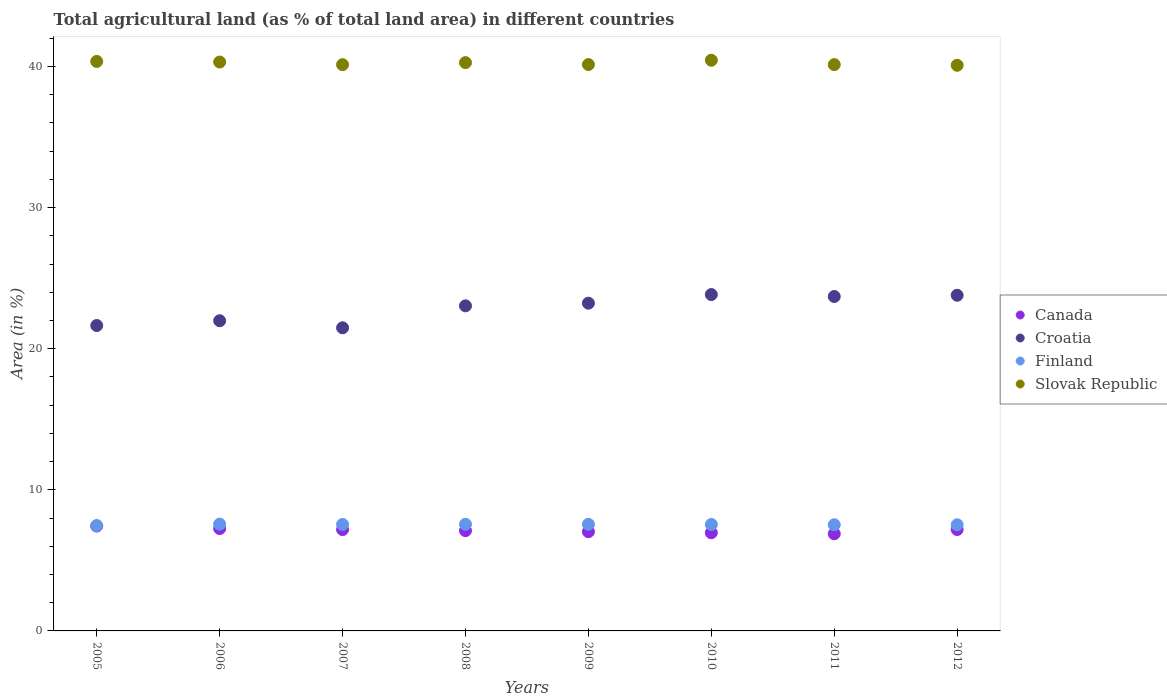How many different coloured dotlines are there?
Your response must be concise. 4. Is the number of dotlines equal to the number of legend labels?
Your response must be concise. Yes. What is the percentage of agricultural land in Slovak Republic in 2010?
Give a very brief answer. 40.44. Across all years, what is the maximum percentage of agricultural land in Croatia?
Offer a terse response. 23.83. Across all years, what is the minimum percentage of agricultural land in Canada?
Offer a very short reply. 6.88. In which year was the percentage of agricultural land in Croatia maximum?
Your response must be concise. 2010. In which year was the percentage of agricultural land in Canada minimum?
Give a very brief answer. 2011. What is the total percentage of agricultural land in Slovak Republic in the graph?
Ensure brevity in your answer.  321.84. What is the difference between the percentage of agricultural land in Croatia in 2005 and that in 2008?
Keep it short and to the point. -1.4. What is the difference between the percentage of agricultural land in Slovak Republic in 2011 and the percentage of agricultural land in Finland in 2009?
Your response must be concise. 32.57. What is the average percentage of agricultural land in Canada per year?
Your response must be concise. 7.13. In the year 2007, what is the difference between the percentage of agricultural land in Croatia and percentage of agricultural land in Canada?
Give a very brief answer. 14.3. What is the ratio of the percentage of agricultural land in Croatia in 2005 to that in 2007?
Provide a succinct answer. 1.01. What is the difference between the highest and the second highest percentage of agricultural land in Finland?
Provide a short and direct response. 0.01. What is the difference between the highest and the lowest percentage of agricultural land in Finland?
Provide a short and direct response. 0.1. Is it the case that in every year, the sum of the percentage of agricultural land in Croatia and percentage of agricultural land in Canada  is greater than the sum of percentage of agricultural land in Slovak Republic and percentage of agricultural land in Finland?
Offer a terse response. Yes. Is the percentage of agricultural land in Finland strictly less than the percentage of agricultural land in Croatia over the years?
Your answer should be very brief. Yes. How many dotlines are there?
Your answer should be compact. 4. How many years are there in the graph?
Offer a terse response. 8. Where does the legend appear in the graph?
Ensure brevity in your answer.  Center right. How many legend labels are there?
Your response must be concise. 4. How are the legend labels stacked?
Offer a terse response. Vertical. What is the title of the graph?
Your answer should be very brief. Total agricultural land (as % of total land area) in different countries. Does "Tonga" appear as one of the legend labels in the graph?
Keep it short and to the point. No. What is the label or title of the Y-axis?
Your answer should be very brief. Area (in %). What is the Area (in %) in Canada in 2005?
Provide a short and direct response. 7.43. What is the Area (in %) in Croatia in 2005?
Provide a short and direct response. 21.64. What is the Area (in %) of Finland in 2005?
Ensure brevity in your answer.  7.47. What is the Area (in %) of Slovak Republic in 2005?
Make the answer very short. 40.35. What is the Area (in %) of Canada in 2006?
Your answer should be compact. 7.25. What is the Area (in %) in Croatia in 2006?
Provide a short and direct response. 21.98. What is the Area (in %) in Finland in 2006?
Your answer should be compact. 7.57. What is the Area (in %) of Slovak Republic in 2006?
Ensure brevity in your answer.  40.31. What is the Area (in %) in Canada in 2007?
Provide a succinct answer. 7.18. What is the Area (in %) of Croatia in 2007?
Make the answer very short. 21.48. What is the Area (in %) in Finland in 2007?
Your response must be concise. 7.55. What is the Area (in %) of Slovak Republic in 2007?
Offer a very short reply. 40.12. What is the Area (in %) of Canada in 2008?
Ensure brevity in your answer.  7.11. What is the Area (in %) of Croatia in 2008?
Offer a terse response. 23.04. What is the Area (in %) in Finland in 2008?
Offer a very short reply. 7.56. What is the Area (in %) of Slovak Republic in 2008?
Your response must be concise. 40.27. What is the Area (in %) of Canada in 2009?
Your answer should be very brief. 7.03. What is the Area (in %) in Croatia in 2009?
Ensure brevity in your answer.  23.22. What is the Area (in %) in Finland in 2009?
Your response must be concise. 7.56. What is the Area (in %) of Slovak Republic in 2009?
Make the answer very short. 40.13. What is the Area (in %) in Canada in 2010?
Provide a short and direct response. 6.96. What is the Area (in %) of Croatia in 2010?
Keep it short and to the point. 23.83. What is the Area (in %) of Finland in 2010?
Keep it short and to the point. 7.54. What is the Area (in %) in Slovak Republic in 2010?
Offer a very short reply. 40.44. What is the Area (in %) in Canada in 2011?
Your answer should be compact. 6.88. What is the Area (in %) of Croatia in 2011?
Make the answer very short. 23.7. What is the Area (in %) of Finland in 2011?
Your answer should be very brief. 7.52. What is the Area (in %) in Slovak Republic in 2011?
Provide a short and direct response. 40.13. What is the Area (in %) in Canada in 2012?
Your response must be concise. 7.19. What is the Area (in %) in Croatia in 2012?
Provide a succinct answer. 23.78. What is the Area (in %) of Finland in 2012?
Keep it short and to the point. 7.52. What is the Area (in %) of Slovak Republic in 2012?
Your response must be concise. 40.08. Across all years, what is the maximum Area (in %) of Canada?
Ensure brevity in your answer.  7.43. Across all years, what is the maximum Area (in %) of Croatia?
Provide a short and direct response. 23.83. Across all years, what is the maximum Area (in %) of Finland?
Provide a short and direct response. 7.57. Across all years, what is the maximum Area (in %) of Slovak Republic?
Your answer should be compact. 40.44. Across all years, what is the minimum Area (in %) of Canada?
Your answer should be compact. 6.88. Across all years, what is the minimum Area (in %) in Croatia?
Keep it short and to the point. 21.48. Across all years, what is the minimum Area (in %) in Finland?
Give a very brief answer. 7.47. Across all years, what is the minimum Area (in %) of Slovak Republic?
Ensure brevity in your answer.  40.08. What is the total Area (in %) in Canada in the graph?
Keep it short and to the point. 57.03. What is the total Area (in %) in Croatia in the graph?
Offer a very short reply. 182.68. What is the total Area (in %) of Finland in the graph?
Make the answer very short. 60.28. What is the total Area (in %) of Slovak Republic in the graph?
Your response must be concise. 321.84. What is the difference between the Area (in %) in Canada in 2005 and that in 2006?
Your answer should be very brief. 0.18. What is the difference between the Area (in %) in Croatia in 2005 and that in 2006?
Your answer should be compact. -0.34. What is the difference between the Area (in %) of Finland in 2005 and that in 2006?
Your response must be concise. -0.1. What is the difference between the Area (in %) in Slovak Republic in 2005 and that in 2006?
Ensure brevity in your answer.  0.04. What is the difference between the Area (in %) in Canada in 2005 and that in 2007?
Provide a succinct answer. 0.25. What is the difference between the Area (in %) of Croatia in 2005 and that in 2007?
Your answer should be compact. 0.16. What is the difference between the Area (in %) in Finland in 2005 and that in 2007?
Make the answer very short. -0.08. What is the difference between the Area (in %) of Slovak Republic in 2005 and that in 2007?
Offer a terse response. 0.23. What is the difference between the Area (in %) in Canada in 2005 and that in 2008?
Your response must be concise. 0.33. What is the difference between the Area (in %) in Croatia in 2005 and that in 2008?
Provide a short and direct response. -1.4. What is the difference between the Area (in %) of Finland in 2005 and that in 2008?
Offer a very short reply. -0.09. What is the difference between the Area (in %) in Slovak Republic in 2005 and that in 2008?
Your answer should be compact. 0.08. What is the difference between the Area (in %) of Canada in 2005 and that in 2009?
Provide a succinct answer. 0.4. What is the difference between the Area (in %) in Croatia in 2005 and that in 2009?
Provide a short and direct response. -1.58. What is the difference between the Area (in %) of Finland in 2005 and that in 2009?
Your answer should be compact. -0.09. What is the difference between the Area (in %) in Slovak Republic in 2005 and that in 2009?
Keep it short and to the point. 0.22. What is the difference between the Area (in %) of Canada in 2005 and that in 2010?
Provide a short and direct response. 0.47. What is the difference between the Area (in %) of Croatia in 2005 and that in 2010?
Offer a very short reply. -2.19. What is the difference between the Area (in %) of Finland in 2005 and that in 2010?
Provide a succinct answer. -0.08. What is the difference between the Area (in %) of Slovak Republic in 2005 and that in 2010?
Ensure brevity in your answer.  -0.08. What is the difference between the Area (in %) of Canada in 2005 and that in 2011?
Your answer should be very brief. 0.55. What is the difference between the Area (in %) in Croatia in 2005 and that in 2011?
Keep it short and to the point. -2.06. What is the difference between the Area (in %) in Finland in 2005 and that in 2011?
Your answer should be very brief. -0.06. What is the difference between the Area (in %) in Slovak Republic in 2005 and that in 2011?
Provide a short and direct response. 0.22. What is the difference between the Area (in %) in Canada in 2005 and that in 2012?
Offer a very short reply. 0.24. What is the difference between the Area (in %) of Croatia in 2005 and that in 2012?
Offer a very short reply. -2.14. What is the difference between the Area (in %) in Finland in 2005 and that in 2012?
Ensure brevity in your answer.  -0.05. What is the difference between the Area (in %) of Slovak Republic in 2005 and that in 2012?
Your response must be concise. 0.27. What is the difference between the Area (in %) in Canada in 2006 and that in 2007?
Provide a succinct answer. 0.07. What is the difference between the Area (in %) of Croatia in 2006 and that in 2007?
Provide a short and direct response. 0.5. What is the difference between the Area (in %) in Finland in 2006 and that in 2007?
Your response must be concise. 0.02. What is the difference between the Area (in %) in Slovak Republic in 2006 and that in 2007?
Your response must be concise. 0.19. What is the difference between the Area (in %) in Canada in 2006 and that in 2008?
Ensure brevity in your answer.  0.15. What is the difference between the Area (in %) of Croatia in 2006 and that in 2008?
Give a very brief answer. -1.06. What is the difference between the Area (in %) in Finland in 2006 and that in 2008?
Offer a very short reply. 0.01. What is the difference between the Area (in %) of Slovak Republic in 2006 and that in 2008?
Offer a very short reply. 0.04. What is the difference between the Area (in %) in Canada in 2006 and that in 2009?
Provide a short and direct response. 0.22. What is the difference between the Area (in %) of Croatia in 2006 and that in 2009?
Your answer should be compact. -1.24. What is the difference between the Area (in %) of Finland in 2006 and that in 2009?
Ensure brevity in your answer.  0.01. What is the difference between the Area (in %) of Slovak Republic in 2006 and that in 2009?
Your response must be concise. 0.18. What is the difference between the Area (in %) in Canada in 2006 and that in 2010?
Give a very brief answer. 0.3. What is the difference between the Area (in %) of Croatia in 2006 and that in 2010?
Your answer should be very brief. -1.85. What is the difference between the Area (in %) in Finland in 2006 and that in 2010?
Give a very brief answer. 0.02. What is the difference between the Area (in %) of Slovak Republic in 2006 and that in 2010?
Make the answer very short. -0.13. What is the difference between the Area (in %) in Canada in 2006 and that in 2011?
Give a very brief answer. 0.37. What is the difference between the Area (in %) of Croatia in 2006 and that in 2011?
Offer a very short reply. -1.72. What is the difference between the Area (in %) in Finland in 2006 and that in 2011?
Offer a very short reply. 0.04. What is the difference between the Area (in %) of Slovak Republic in 2006 and that in 2011?
Ensure brevity in your answer.  0.18. What is the difference between the Area (in %) in Canada in 2006 and that in 2012?
Ensure brevity in your answer.  0.07. What is the difference between the Area (in %) in Croatia in 2006 and that in 2012?
Provide a succinct answer. -1.8. What is the difference between the Area (in %) in Finland in 2006 and that in 2012?
Give a very brief answer. 0.05. What is the difference between the Area (in %) of Slovak Republic in 2006 and that in 2012?
Offer a very short reply. 0.23. What is the difference between the Area (in %) in Canada in 2007 and that in 2008?
Provide a succinct answer. 0.07. What is the difference between the Area (in %) in Croatia in 2007 and that in 2008?
Provide a succinct answer. -1.56. What is the difference between the Area (in %) of Finland in 2007 and that in 2008?
Your response must be concise. -0.01. What is the difference between the Area (in %) of Slovak Republic in 2007 and that in 2008?
Your response must be concise. -0.15. What is the difference between the Area (in %) in Canada in 2007 and that in 2009?
Your answer should be compact. 0.15. What is the difference between the Area (in %) of Croatia in 2007 and that in 2009?
Your answer should be compact. -1.74. What is the difference between the Area (in %) in Finland in 2007 and that in 2009?
Keep it short and to the point. -0.01. What is the difference between the Area (in %) in Slovak Republic in 2007 and that in 2009?
Ensure brevity in your answer.  -0.01. What is the difference between the Area (in %) in Canada in 2007 and that in 2010?
Your answer should be compact. 0.22. What is the difference between the Area (in %) in Croatia in 2007 and that in 2010?
Provide a succinct answer. -2.36. What is the difference between the Area (in %) of Finland in 2007 and that in 2010?
Your answer should be compact. 0.01. What is the difference between the Area (in %) in Slovak Republic in 2007 and that in 2010?
Provide a succinct answer. -0.31. What is the difference between the Area (in %) of Canada in 2007 and that in 2011?
Your answer should be very brief. 0.3. What is the difference between the Area (in %) of Croatia in 2007 and that in 2011?
Provide a short and direct response. -2.22. What is the difference between the Area (in %) of Finland in 2007 and that in 2011?
Give a very brief answer. 0.02. What is the difference between the Area (in %) of Slovak Republic in 2007 and that in 2011?
Offer a terse response. -0. What is the difference between the Area (in %) in Canada in 2007 and that in 2012?
Offer a terse response. -0.01. What is the difference between the Area (in %) in Croatia in 2007 and that in 2012?
Offer a very short reply. -2.31. What is the difference between the Area (in %) of Finland in 2007 and that in 2012?
Your response must be concise. 0.03. What is the difference between the Area (in %) of Slovak Republic in 2007 and that in 2012?
Offer a very short reply. 0.04. What is the difference between the Area (in %) of Canada in 2008 and that in 2009?
Give a very brief answer. 0.07. What is the difference between the Area (in %) in Croatia in 2008 and that in 2009?
Keep it short and to the point. -0.19. What is the difference between the Area (in %) of Finland in 2008 and that in 2009?
Ensure brevity in your answer.  -0. What is the difference between the Area (in %) in Slovak Republic in 2008 and that in 2009?
Make the answer very short. 0.14. What is the difference between the Area (in %) in Canada in 2008 and that in 2010?
Provide a short and direct response. 0.15. What is the difference between the Area (in %) of Croatia in 2008 and that in 2010?
Provide a succinct answer. -0.8. What is the difference between the Area (in %) in Finland in 2008 and that in 2010?
Keep it short and to the point. 0.01. What is the difference between the Area (in %) in Slovak Republic in 2008 and that in 2010?
Give a very brief answer. -0.17. What is the difference between the Area (in %) in Canada in 2008 and that in 2011?
Ensure brevity in your answer.  0.22. What is the difference between the Area (in %) in Croatia in 2008 and that in 2011?
Your answer should be compact. -0.66. What is the difference between the Area (in %) in Finland in 2008 and that in 2011?
Offer a very short reply. 0.03. What is the difference between the Area (in %) in Slovak Republic in 2008 and that in 2011?
Your response must be concise. 0.14. What is the difference between the Area (in %) in Canada in 2008 and that in 2012?
Provide a succinct answer. -0.08. What is the difference between the Area (in %) of Croatia in 2008 and that in 2012?
Ensure brevity in your answer.  -0.75. What is the difference between the Area (in %) in Finland in 2008 and that in 2012?
Your answer should be very brief. 0.04. What is the difference between the Area (in %) in Slovak Republic in 2008 and that in 2012?
Your answer should be compact. 0.19. What is the difference between the Area (in %) in Canada in 2009 and that in 2010?
Your answer should be compact. 0.07. What is the difference between the Area (in %) of Croatia in 2009 and that in 2010?
Ensure brevity in your answer.  -0.61. What is the difference between the Area (in %) of Finland in 2009 and that in 2010?
Keep it short and to the point. 0.02. What is the difference between the Area (in %) of Slovak Republic in 2009 and that in 2010?
Your answer should be compact. -0.3. What is the difference between the Area (in %) in Canada in 2009 and that in 2011?
Provide a short and direct response. 0.15. What is the difference between the Area (in %) of Croatia in 2009 and that in 2011?
Your response must be concise. -0.47. What is the difference between the Area (in %) of Finland in 2009 and that in 2011?
Provide a succinct answer. 0.03. What is the difference between the Area (in %) in Slovak Republic in 2009 and that in 2011?
Provide a succinct answer. 0. What is the difference between the Area (in %) of Canada in 2009 and that in 2012?
Provide a short and direct response. -0.15. What is the difference between the Area (in %) of Croatia in 2009 and that in 2012?
Keep it short and to the point. -0.56. What is the difference between the Area (in %) of Finland in 2009 and that in 2012?
Provide a short and direct response. 0.04. What is the difference between the Area (in %) in Slovak Republic in 2009 and that in 2012?
Make the answer very short. 0.05. What is the difference between the Area (in %) in Canada in 2010 and that in 2011?
Give a very brief answer. 0.07. What is the difference between the Area (in %) of Croatia in 2010 and that in 2011?
Keep it short and to the point. 0.14. What is the difference between the Area (in %) in Finland in 2010 and that in 2011?
Offer a terse response. 0.02. What is the difference between the Area (in %) in Slovak Republic in 2010 and that in 2011?
Your answer should be very brief. 0.31. What is the difference between the Area (in %) of Canada in 2010 and that in 2012?
Keep it short and to the point. -0.23. What is the difference between the Area (in %) of Finland in 2010 and that in 2012?
Offer a very short reply. 0.02. What is the difference between the Area (in %) of Slovak Republic in 2010 and that in 2012?
Give a very brief answer. 0.36. What is the difference between the Area (in %) of Canada in 2011 and that in 2012?
Offer a very short reply. -0.3. What is the difference between the Area (in %) of Croatia in 2011 and that in 2012?
Keep it short and to the point. -0.09. What is the difference between the Area (in %) of Finland in 2011 and that in 2012?
Provide a succinct answer. 0. What is the difference between the Area (in %) of Slovak Republic in 2011 and that in 2012?
Ensure brevity in your answer.  0.05. What is the difference between the Area (in %) of Canada in 2005 and the Area (in %) of Croatia in 2006?
Your response must be concise. -14.55. What is the difference between the Area (in %) in Canada in 2005 and the Area (in %) in Finland in 2006?
Ensure brevity in your answer.  -0.14. What is the difference between the Area (in %) in Canada in 2005 and the Area (in %) in Slovak Republic in 2006?
Give a very brief answer. -32.88. What is the difference between the Area (in %) in Croatia in 2005 and the Area (in %) in Finland in 2006?
Give a very brief answer. 14.07. What is the difference between the Area (in %) in Croatia in 2005 and the Area (in %) in Slovak Republic in 2006?
Give a very brief answer. -18.67. What is the difference between the Area (in %) in Finland in 2005 and the Area (in %) in Slovak Republic in 2006?
Provide a succinct answer. -32.85. What is the difference between the Area (in %) of Canada in 2005 and the Area (in %) of Croatia in 2007?
Make the answer very short. -14.05. What is the difference between the Area (in %) in Canada in 2005 and the Area (in %) in Finland in 2007?
Your response must be concise. -0.12. What is the difference between the Area (in %) of Canada in 2005 and the Area (in %) of Slovak Republic in 2007?
Provide a succinct answer. -32.69. What is the difference between the Area (in %) of Croatia in 2005 and the Area (in %) of Finland in 2007?
Your answer should be compact. 14.09. What is the difference between the Area (in %) in Croatia in 2005 and the Area (in %) in Slovak Republic in 2007?
Your answer should be very brief. -18.48. What is the difference between the Area (in %) of Finland in 2005 and the Area (in %) of Slovak Republic in 2007?
Provide a succinct answer. -32.66. What is the difference between the Area (in %) in Canada in 2005 and the Area (in %) in Croatia in 2008?
Offer a very short reply. -15.61. What is the difference between the Area (in %) in Canada in 2005 and the Area (in %) in Finland in 2008?
Make the answer very short. -0.13. What is the difference between the Area (in %) of Canada in 2005 and the Area (in %) of Slovak Republic in 2008?
Offer a very short reply. -32.84. What is the difference between the Area (in %) in Croatia in 2005 and the Area (in %) in Finland in 2008?
Provide a short and direct response. 14.08. What is the difference between the Area (in %) of Croatia in 2005 and the Area (in %) of Slovak Republic in 2008?
Your response must be concise. -18.63. What is the difference between the Area (in %) in Finland in 2005 and the Area (in %) in Slovak Republic in 2008?
Provide a succinct answer. -32.81. What is the difference between the Area (in %) in Canada in 2005 and the Area (in %) in Croatia in 2009?
Offer a very short reply. -15.79. What is the difference between the Area (in %) in Canada in 2005 and the Area (in %) in Finland in 2009?
Provide a succinct answer. -0.13. What is the difference between the Area (in %) in Canada in 2005 and the Area (in %) in Slovak Republic in 2009?
Offer a terse response. -32.7. What is the difference between the Area (in %) in Croatia in 2005 and the Area (in %) in Finland in 2009?
Give a very brief answer. 14.08. What is the difference between the Area (in %) of Croatia in 2005 and the Area (in %) of Slovak Republic in 2009?
Keep it short and to the point. -18.49. What is the difference between the Area (in %) of Finland in 2005 and the Area (in %) of Slovak Republic in 2009?
Ensure brevity in your answer.  -32.67. What is the difference between the Area (in %) of Canada in 2005 and the Area (in %) of Croatia in 2010?
Provide a succinct answer. -16.4. What is the difference between the Area (in %) of Canada in 2005 and the Area (in %) of Finland in 2010?
Your answer should be compact. -0.11. What is the difference between the Area (in %) of Canada in 2005 and the Area (in %) of Slovak Republic in 2010?
Your answer should be very brief. -33.01. What is the difference between the Area (in %) in Croatia in 2005 and the Area (in %) in Finland in 2010?
Your answer should be very brief. 14.1. What is the difference between the Area (in %) of Croatia in 2005 and the Area (in %) of Slovak Republic in 2010?
Offer a terse response. -18.8. What is the difference between the Area (in %) of Finland in 2005 and the Area (in %) of Slovak Republic in 2010?
Offer a terse response. -32.97. What is the difference between the Area (in %) in Canada in 2005 and the Area (in %) in Croatia in 2011?
Offer a very short reply. -16.27. What is the difference between the Area (in %) in Canada in 2005 and the Area (in %) in Finland in 2011?
Your answer should be compact. -0.09. What is the difference between the Area (in %) of Canada in 2005 and the Area (in %) of Slovak Republic in 2011?
Your answer should be compact. -32.7. What is the difference between the Area (in %) of Croatia in 2005 and the Area (in %) of Finland in 2011?
Offer a very short reply. 14.12. What is the difference between the Area (in %) in Croatia in 2005 and the Area (in %) in Slovak Republic in 2011?
Your response must be concise. -18.49. What is the difference between the Area (in %) in Finland in 2005 and the Area (in %) in Slovak Republic in 2011?
Your answer should be compact. -32.66. What is the difference between the Area (in %) of Canada in 2005 and the Area (in %) of Croatia in 2012?
Ensure brevity in your answer.  -16.35. What is the difference between the Area (in %) in Canada in 2005 and the Area (in %) in Finland in 2012?
Offer a terse response. -0.09. What is the difference between the Area (in %) of Canada in 2005 and the Area (in %) of Slovak Republic in 2012?
Make the answer very short. -32.65. What is the difference between the Area (in %) in Croatia in 2005 and the Area (in %) in Finland in 2012?
Offer a terse response. 14.12. What is the difference between the Area (in %) of Croatia in 2005 and the Area (in %) of Slovak Republic in 2012?
Your response must be concise. -18.44. What is the difference between the Area (in %) in Finland in 2005 and the Area (in %) in Slovak Republic in 2012?
Your answer should be very brief. -32.62. What is the difference between the Area (in %) of Canada in 2006 and the Area (in %) of Croatia in 2007?
Give a very brief answer. -14.23. What is the difference between the Area (in %) in Canada in 2006 and the Area (in %) in Finland in 2007?
Offer a terse response. -0.29. What is the difference between the Area (in %) of Canada in 2006 and the Area (in %) of Slovak Republic in 2007?
Your response must be concise. -32.87. What is the difference between the Area (in %) in Croatia in 2006 and the Area (in %) in Finland in 2007?
Give a very brief answer. 14.43. What is the difference between the Area (in %) of Croatia in 2006 and the Area (in %) of Slovak Republic in 2007?
Give a very brief answer. -18.14. What is the difference between the Area (in %) of Finland in 2006 and the Area (in %) of Slovak Republic in 2007?
Provide a succinct answer. -32.56. What is the difference between the Area (in %) in Canada in 2006 and the Area (in %) in Croatia in 2008?
Your answer should be compact. -15.78. What is the difference between the Area (in %) of Canada in 2006 and the Area (in %) of Finland in 2008?
Your answer should be very brief. -0.3. What is the difference between the Area (in %) in Canada in 2006 and the Area (in %) in Slovak Republic in 2008?
Your response must be concise. -33.02. What is the difference between the Area (in %) of Croatia in 2006 and the Area (in %) of Finland in 2008?
Ensure brevity in your answer.  14.42. What is the difference between the Area (in %) of Croatia in 2006 and the Area (in %) of Slovak Republic in 2008?
Your response must be concise. -18.29. What is the difference between the Area (in %) of Finland in 2006 and the Area (in %) of Slovak Republic in 2008?
Make the answer very short. -32.7. What is the difference between the Area (in %) of Canada in 2006 and the Area (in %) of Croatia in 2009?
Give a very brief answer. -15.97. What is the difference between the Area (in %) in Canada in 2006 and the Area (in %) in Finland in 2009?
Your answer should be very brief. -0.3. What is the difference between the Area (in %) of Canada in 2006 and the Area (in %) of Slovak Republic in 2009?
Keep it short and to the point. -32.88. What is the difference between the Area (in %) of Croatia in 2006 and the Area (in %) of Finland in 2009?
Ensure brevity in your answer.  14.42. What is the difference between the Area (in %) of Croatia in 2006 and the Area (in %) of Slovak Republic in 2009?
Give a very brief answer. -18.15. What is the difference between the Area (in %) in Finland in 2006 and the Area (in %) in Slovak Republic in 2009?
Your response must be concise. -32.57. What is the difference between the Area (in %) of Canada in 2006 and the Area (in %) of Croatia in 2010?
Make the answer very short. -16.58. What is the difference between the Area (in %) of Canada in 2006 and the Area (in %) of Finland in 2010?
Give a very brief answer. -0.29. What is the difference between the Area (in %) in Canada in 2006 and the Area (in %) in Slovak Republic in 2010?
Your answer should be very brief. -33.19. What is the difference between the Area (in %) of Croatia in 2006 and the Area (in %) of Finland in 2010?
Keep it short and to the point. 14.44. What is the difference between the Area (in %) of Croatia in 2006 and the Area (in %) of Slovak Republic in 2010?
Your answer should be very brief. -18.46. What is the difference between the Area (in %) of Finland in 2006 and the Area (in %) of Slovak Republic in 2010?
Make the answer very short. -32.87. What is the difference between the Area (in %) of Canada in 2006 and the Area (in %) of Croatia in 2011?
Keep it short and to the point. -16.44. What is the difference between the Area (in %) in Canada in 2006 and the Area (in %) in Finland in 2011?
Your answer should be very brief. -0.27. What is the difference between the Area (in %) in Canada in 2006 and the Area (in %) in Slovak Republic in 2011?
Your answer should be compact. -32.88. What is the difference between the Area (in %) in Croatia in 2006 and the Area (in %) in Finland in 2011?
Make the answer very short. 14.46. What is the difference between the Area (in %) in Croatia in 2006 and the Area (in %) in Slovak Republic in 2011?
Ensure brevity in your answer.  -18.15. What is the difference between the Area (in %) in Finland in 2006 and the Area (in %) in Slovak Republic in 2011?
Ensure brevity in your answer.  -32.56. What is the difference between the Area (in %) of Canada in 2006 and the Area (in %) of Croatia in 2012?
Keep it short and to the point. -16.53. What is the difference between the Area (in %) in Canada in 2006 and the Area (in %) in Finland in 2012?
Keep it short and to the point. -0.27. What is the difference between the Area (in %) in Canada in 2006 and the Area (in %) in Slovak Republic in 2012?
Your response must be concise. -32.83. What is the difference between the Area (in %) of Croatia in 2006 and the Area (in %) of Finland in 2012?
Give a very brief answer. 14.46. What is the difference between the Area (in %) of Croatia in 2006 and the Area (in %) of Slovak Republic in 2012?
Ensure brevity in your answer.  -18.1. What is the difference between the Area (in %) in Finland in 2006 and the Area (in %) in Slovak Republic in 2012?
Your answer should be compact. -32.52. What is the difference between the Area (in %) of Canada in 2007 and the Area (in %) of Croatia in 2008?
Your response must be concise. -15.86. What is the difference between the Area (in %) of Canada in 2007 and the Area (in %) of Finland in 2008?
Make the answer very short. -0.38. What is the difference between the Area (in %) of Canada in 2007 and the Area (in %) of Slovak Republic in 2008?
Your response must be concise. -33.09. What is the difference between the Area (in %) in Croatia in 2007 and the Area (in %) in Finland in 2008?
Your answer should be very brief. 13.92. What is the difference between the Area (in %) in Croatia in 2007 and the Area (in %) in Slovak Republic in 2008?
Keep it short and to the point. -18.79. What is the difference between the Area (in %) of Finland in 2007 and the Area (in %) of Slovak Republic in 2008?
Provide a succinct answer. -32.72. What is the difference between the Area (in %) of Canada in 2007 and the Area (in %) of Croatia in 2009?
Make the answer very short. -16.04. What is the difference between the Area (in %) in Canada in 2007 and the Area (in %) in Finland in 2009?
Offer a very short reply. -0.38. What is the difference between the Area (in %) of Canada in 2007 and the Area (in %) of Slovak Republic in 2009?
Offer a very short reply. -32.95. What is the difference between the Area (in %) of Croatia in 2007 and the Area (in %) of Finland in 2009?
Offer a very short reply. 13.92. What is the difference between the Area (in %) in Croatia in 2007 and the Area (in %) in Slovak Republic in 2009?
Your answer should be very brief. -18.65. What is the difference between the Area (in %) in Finland in 2007 and the Area (in %) in Slovak Republic in 2009?
Give a very brief answer. -32.59. What is the difference between the Area (in %) in Canada in 2007 and the Area (in %) in Croatia in 2010?
Offer a terse response. -16.66. What is the difference between the Area (in %) in Canada in 2007 and the Area (in %) in Finland in 2010?
Your response must be concise. -0.36. What is the difference between the Area (in %) of Canada in 2007 and the Area (in %) of Slovak Republic in 2010?
Offer a very short reply. -33.26. What is the difference between the Area (in %) in Croatia in 2007 and the Area (in %) in Finland in 2010?
Provide a succinct answer. 13.94. What is the difference between the Area (in %) in Croatia in 2007 and the Area (in %) in Slovak Republic in 2010?
Provide a short and direct response. -18.96. What is the difference between the Area (in %) of Finland in 2007 and the Area (in %) of Slovak Republic in 2010?
Offer a very short reply. -32.89. What is the difference between the Area (in %) in Canada in 2007 and the Area (in %) in Croatia in 2011?
Your answer should be very brief. -16.52. What is the difference between the Area (in %) in Canada in 2007 and the Area (in %) in Finland in 2011?
Keep it short and to the point. -0.35. What is the difference between the Area (in %) in Canada in 2007 and the Area (in %) in Slovak Republic in 2011?
Your answer should be compact. -32.95. What is the difference between the Area (in %) in Croatia in 2007 and the Area (in %) in Finland in 2011?
Keep it short and to the point. 13.96. What is the difference between the Area (in %) of Croatia in 2007 and the Area (in %) of Slovak Republic in 2011?
Make the answer very short. -18.65. What is the difference between the Area (in %) of Finland in 2007 and the Area (in %) of Slovak Republic in 2011?
Offer a very short reply. -32.58. What is the difference between the Area (in %) in Canada in 2007 and the Area (in %) in Croatia in 2012?
Make the answer very short. -16.61. What is the difference between the Area (in %) of Canada in 2007 and the Area (in %) of Finland in 2012?
Provide a short and direct response. -0.34. What is the difference between the Area (in %) of Canada in 2007 and the Area (in %) of Slovak Republic in 2012?
Provide a succinct answer. -32.9. What is the difference between the Area (in %) in Croatia in 2007 and the Area (in %) in Finland in 2012?
Provide a succinct answer. 13.96. What is the difference between the Area (in %) of Croatia in 2007 and the Area (in %) of Slovak Republic in 2012?
Your answer should be very brief. -18.6. What is the difference between the Area (in %) in Finland in 2007 and the Area (in %) in Slovak Republic in 2012?
Keep it short and to the point. -32.53. What is the difference between the Area (in %) in Canada in 2008 and the Area (in %) in Croatia in 2009?
Offer a terse response. -16.12. What is the difference between the Area (in %) in Canada in 2008 and the Area (in %) in Finland in 2009?
Provide a succinct answer. -0.45. What is the difference between the Area (in %) of Canada in 2008 and the Area (in %) of Slovak Republic in 2009?
Ensure brevity in your answer.  -33.03. What is the difference between the Area (in %) of Croatia in 2008 and the Area (in %) of Finland in 2009?
Your answer should be very brief. 15.48. What is the difference between the Area (in %) of Croatia in 2008 and the Area (in %) of Slovak Republic in 2009?
Your answer should be very brief. -17.1. What is the difference between the Area (in %) in Finland in 2008 and the Area (in %) in Slovak Republic in 2009?
Offer a very short reply. -32.58. What is the difference between the Area (in %) in Canada in 2008 and the Area (in %) in Croatia in 2010?
Your answer should be very brief. -16.73. What is the difference between the Area (in %) in Canada in 2008 and the Area (in %) in Finland in 2010?
Ensure brevity in your answer.  -0.44. What is the difference between the Area (in %) of Canada in 2008 and the Area (in %) of Slovak Republic in 2010?
Offer a very short reply. -33.33. What is the difference between the Area (in %) of Croatia in 2008 and the Area (in %) of Finland in 2010?
Make the answer very short. 15.49. What is the difference between the Area (in %) of Croatia in 2008 and the Area (in %) of Slovak Republic in 2010?
Your response must be concise. -17.4. What is the difference between the Area (in %) in Finland in 2008 and the Area (in %) in Slovak Republic in 2010?
Offer a terse response. -32.88. What is the difference between the Area (in %) in Canada in 2008 and the Area (in %) in Croatia in 2011?
Offer a terse response. -16.59. What is the difference between the Area (in %) in Canada in 2008 and the Area (in %) in Finland in 2011?
Offer a very short reply. -0.42. What is the difference between the Area (in %) of Canada in 2008 and the Area (in %) of Slovak Republic in 2011?
Your answer should be very brief. -33.02. What is the difference between the Area (in %) in Croatia in 2008 and the Area (in %) in Finland in 2011?
Make the answer very short. 15.51. What is the difference between the Area (in %) in Croatia in 2008 and the Area (in %) in Slovak Republic in 2011?
Give a very brief answer. -17.09. What is the difference between the Area (in %) of Finland in 2008 and the Area (in %) of Slovak Republic in 2011?
Your response must be concise. -32.57. What is the difference between the Area (in %) in Canada in 2008 and the Area (in %) in Croatia in 2012?
Offer a terse response. -16.68. What is the difference between the Area (in %) of Canada in 2008 and the Area (in %) of Finland in 2012?
Make the answer very short. -0.41. What is the difference between the Area (in %) in Canada in 2008 and the Area (in %) in Slovak Republic in 2012?
Keep it short and to the point. -32.98. What is the difference between the Area (in %) of Croatia in 2008 and the Area (in %) of Finland in 2012?
Make the answer very short. 15.52. What is the difference between the Area (in %) of Croatia in 2008 and the Area (in %) of Slovak Republic in 2012?
Provide a short and direct response. -17.04. What is the difference between the Area (in %) in Finland in 2008 and the Area (in %) in Slovak Republic in 2012?
Your response must be concise. -32.52. What is the difference between the Area (in %) in Canada in 2009 and the Area (in %) in Croatia in 2010?
Make the answer very short. -16.8. What is the difference between the Area (in %) in Canada in 2009 and the Area (in %) in Finland in 2010?
Offer a very short reply. -0.51. What is the difference between the Area (in %) in Canada in 2009 and the Area (in %) in Slovak Republic in 2010?
Make the answer very short. -33.41. What is the difference between the Area (in %) in Croatia in 2009 and the Area (in %) in Finland in 2010?
Make the answer very short. 15.68. What is the difference between the Area (in %) of Croatia in 2009 and the Area (in %) of Slovak Republic in 2010?
Your answer should be very brief. -17.21. What is the difference between the Area (in %) of Finland in 2009 and the Area (in %) of Slovak Republic in 2010?
Your answer should be compact. -32.88. What is the difference between the Area (in %) of Canada in 2009 and the Area (in %) of Croatia in 2011?
Provide a succinct answer. -16.67. What is the difference between the Area (in %) of Canada in 2009 and the Area (in %) of Finland in 2011?
Your answer should be very brief. -0.49. What is the difference between the Area (in %) of Canada in 2009 and the Area (in %) of Slovak Republic in 2011?
Offer a very short reply. -33.1. What is the difference between the Area (in %) of Croatia in 2009 and the Area (in %) of Finland in 2011?
Give a very brief answer. 15.7. What is the difference between the Area (in %) in Croatia in 2009 and the Area (in %) in Slovak Republic in 2011?
Ensure brevity in your answer.  -16.9. What is the difference between the Area (in %) of Finland in 2009 and the Area (in %) of Slovak Republic in 2011?
Offer a terse response. -32.57. What is the difference between the Area (in %) in Canada in 2009 and the Area (in %) in Croatia in 2012?
Offer a terse response. -16.75. What is the difference between the Area (in %) in Canada in 2009 and the Area (in %) in Finland in 2012?
Your answer should be compact. -0.49. What is the difference between the Area (in %) in Canada in 2009 and the Area (in %) in Slovak Republic in 2012?
Keep it short and to the point. -33.05. What is the difference between the Area (in %) in Croatia in 2009 and the Area (in %) in Finland in 2012?
Offer a terse response. 15.7. What is the difference between the Area (in %) in Croatia in 2009 and the Area (in %) in Slovak Republic in 2012?
Your response must be concise. -16.86. What is the difference between the Area (in %) in Finland in 2009 and the Area (in %) in Slovak Republic in 2012?
Provide a short and direct response. -32.52. What is the difference between the Area (in %) in Canada in 2010 and the Area (in %) in Croatia in 2011?
Offer a very short reply. -16.74. What is the difference between the Area (in %) of Canada in 2010 and the Area (in %) of Finland in 2011?
Provide a succinct answer. -0.57. What is the difference between the Area (in %) in Canada in 2010 and the Area (in %) in Slovak Republic in 2011?
Your answer should be very brief. -33.17. What is the difference between the Area (in %) in Croatia in 2010 and the Area (in %) in Finland in 2011?
Offer a terse response. 16.31. What is the difference between the Area (in %) in Croatia in 2010 and the Area (in %) in Slovak Republic in 2011?
Ensure brevity in your answer.  -16.29. What is the difference between the Area (in %) in Finland in 2010 and the Area (in %) in Slovak Republic in 2011?
Your answer should be very brief. -32.59. What is the difference between the Area (in %) in Canada in 2010 and the Area (in %) in Croatia in 2012?
Offer a very short reply. -16.83. What is the difference between the Area (in %) in Canada in 2010 and the Area (in %) in Finland in 2012?
Make the answer very short. -0.56. What is the difference between the Area (in %) in Canada in 2010 and the Area (in %) in Slovak Republic in 2012?
Give a very brief answer. -33.12. What is the difference between the Area (in %) of Croatia in 2010 and the Area (in %) of Finland in 2012?
Offer a terse response. 16.32. What is the difference between the Area (in %) of Croatia in 2010 and the Area (in %) of Slovak Republic in 2012?
Your response must be concise. -16.25. What is the difference between the Area (in %) of Finland in 2010 and the Area (in %) of Slovak Republic in 2012?
Provide a succinct answer. -32.54. What is the difference between the Area (in %) of Canada in 2011 and the Area (in %) of Croatia in 2012?
Your answer should be compact. -16.9. What is the difference between the Area (in %) of Canada in 2011 and the Area (in %) of Finland in 2012?
Keep it short and to the point. -0.64. What is the difference between the Area (in %) of Canada in 2011 and the Area (in %) of Slovak Republic in 2012?
Your response must be concise. -33.2. What is the difference between the Area (in %) in Croatia in 2011 and the Area (in %) in Finland in 2012?
Offer a very short reply. 16.18. What is the difference between the Area (in %) of Croatia in 2011 and the Area (in %) of Slovak Republic in 2012?
Keep it short and to the point. -16.38. What is the difference between the Area (in %) in Finland in 2011 and the Area (in %) in Slovak Republic in 2012?
Ensure brevity in your answer.  -32.56. What is the average Area (in %) in Canada per year?
Your answer should be compact. 7.13. What is the average Area (in %) of Croatia per year?
Your answer should be very brief. 22.83. What is the average Area (in %) of Finland per year?
Your answer should be compact. 7.53. What is the average Area (in %) of Slovak Republic per year?
Your answer should be very brief. 40.23. In the year 2005, what is the difference between the Area (in %) of Canada and Area (in %) of Croatia?
Your response must be concise. -14.21. In the year 2005, what is the difference between the Area (in %) of Canada and Area (in %) of Finland?
Offer a very short reply. -0.03. In the year 2005, what is the difference between the Area (in %) of Canada and Area (in %) of Slovak Republic?
Provide a succinct answer. -32.92. In the year 2005, what is the difference between the Area (in %) in Croatia and Area (in %) in Finland?
Your answer should be very brief. 14.18. In the year 2005, what is the difference between the Area (in %) in Croatia and Area (in %) in Slovak Republic?
Your answer should be very brief. -18.71. In the year 2005, what is the difference between the Area (in %) in Finland and Area (in %) in Slovak Republic?
Keep it short and to the point. -32.89. In the year 2006, what is the difference between the Area (in %) of Canada and Area (in %) of Croatia?
Your response must be concise. -14.73. In the year 2006, what is the difference between the Area (in %) of Canada and Area (in %) of Finland?
Provide a short and direct response. -0.31. In the year 2006, what is the difference between the Area (in %) of Canada and Area (in %) of Slovak Republic?
Make the answer very short. -33.06. In the year 2006, what is the difference between the Area (in %) of Croatia and Area (in %) of Finland?
Your answer should be compact. 14.41. In the year 2006, what is the difference between the Area (in %) of Croatia and Area (in %) of Slovak Republic?
Keep it short and to the point. -18.33. In the year 2006, what is the difference between the Area (in %) in Finland and Area (in %) in Slovak Republic?
Keep it short and to the point. -32.75. In the year 2007, what is the difference between the Area (in %) in Canada and Area (in %) in Croatia?
Your answer should be very brief. -14.3. In the year 2007, what is the difference between the Area (in %) in Canada and Area (in %) in Finland?
Your answer should be compact. -0.37. In the year 2007, what is the difference between the Area (in %) in Canada and Area (in %) in Slovak Republic?
Your answer should be compact. -32.95. In the year 2007, what is the difference between the Area (in %) in Croatia and Area (in %) in Finland?
Ensure brevity in your answer.  13.93. In the year 2007, what is the difference between the Area (in %) of Croatia and Area (in %) of Slovak Republic?
Offer a terse response. -18.65. In the year 2007, what is the difference between the Area (in %) in Finland and Area (in %) in Slovak Republic?
Your response must be concise. -32.58. In the year 2008, what is the difference between the Area (in %) in Canada and Area (in %) in Croatia?
Your answer should be very brief. -15.93. In the year 2008, what is the difference between the Area (in %) of Canada and Area (in %) of Finland?
Your answer should be compact. -0.45. In the year 2008, what is the difference between the Area (in %) in Canada and Area (in %) in Slovak Republic?
Provide a succinct answer. -33.17. In the year 2008, what is the difference between the Area (in %) in Croatia and Area (in %) in Finland?
Keep it short and to the point. 15.48. In the year 2008, what is the difference between the Area (in %) of Croatia and Area (in %) of Slovak Republic?
Ensure brevity in your answer.  -17.23. In the year 2008, what is the difference between the Area (in %) of Finland and Area (in %) of Slovak Republic?
Your response must be concise. -32.71. In the year 2009, what is the difference between the Area (in %) in Canada and Area (in %) in Croatia?
Give a very brief answer. -16.19. In the year 2009, what is the difference between the Area (in %) in Canada and Area (in %) in Finland?
Your response must be concise. -0.53. In the year 2009, what is the difference between the Area (in %) in Canada and Area (in %) in Slovak Republic?
Offer a very short reply. -33.1. In the year 2009, what is the difference between the Area (in %) in Croatia and Area (in %) in Finland?
Provide a short and direct response. 15.67. In the year 2009, what is the difference between the Area (in %) of Croatia and Area (in %) of Slovak Republic?
Your answer should be compact. -16.91. In the year 2009, what is the difference between the Area (in %) of Finland and Area (in %) of Slovak Republic?
Provide a short and direct response. -32.58. In the year 2010, what is the difference between the Area (in %) in Canada and Area (in %) in Croatia?
Your answer should be very brief. -16.88. In the year 2010, what is the difference between the Area (in %) in Canada and Area (in %) in Finland?
Offer a terse response. -0.58. In the year 2010, what is the difference between the Area (in %) of Canada and Area (in %) of Slovak Republic?
Offer a terse response. -33.48. In the year 2010, what is the difference between the Area (in %) of Croatia and Area (in %) of Finland?
Give a very brief answer. 16.29. In the year 2010, what is the difference between the Area (in %) in Croatia and Area (in %) in Slovak Republic?
Make the answer very short. -16.6. In the year 2010, what is the difference between the Area (in %) in Finland and Area (in %) in Slovak Republic?
Offer a very short reply. -32.9. In the year 2011, what is the difference between the Area (in %) in Canada and Area (in %) in Croatia?
Your answer should be very brief. -16.81. In the year 2011, what is the difference between the Area (in %) in Canada and Area (in %) in Finland?
Make the answer very short. -0.64. In the year 2011, what is the difference between the Area (in %) of Canada and Area (in %) of Slovak Republic?
Ensure brevity in your answer.  -33.24. In the year 2011, what is the difference between the Area (in %) in Croatia and Area (in %) in Finland?
Offer a very short reply. 16.17. In the year 2011, what is the difference between the Area (in %) in Croatia and Area (in %) in Slovak Republic?
Offer a very short reply. -16.43. In the year 2011, what is the difference between the Area (in %) in Finland and Area (in %) in Slovak Republic?
Your answer should be very brief. -32.6. In the year 2012, what is the difference between the Area (in %) of Canada and Area (in %) of Croatia?
Give a very brief answer. -16.6. In the year 2012, what is the difference between the Area (in %) in Canada and Area (in %) in Finland?
Your response must be concise. -0.33. In the year 2012, what is the difference between the Area (in %) in Canada and Area (in %) in Slovak Republic?
Make the answer very short. -32.89. In the year 2012, what is the difference between the Area (in %) of Croatia and Area (in %) of Finland?
Ensure brevity in your answer.  16.27. In the year 2012, what is the difference between the Area (in %) in Croatia and Area (in %) in Slovak Republic?
Offer a terse response. -16.3. In the year 2012, what is the difference between the Area (in %) of Finland and Area (in %) of Slovak Republic?
Ensure brevity in your answer.  -32.56. What is the ratio of the Area (in %) of Canada in 2005 to that in 2006?
Provide a short and direct response. 1.02. What is the ratio of the Area (in %) in Croatia in 2005 to that in 2006?
Your response must be concise. 0.98. What is the ratio of the Area (in %) in Finland in 2005 to that in 2006?
Keep it short and to the point. 0.99. What is the ratio of the Area (in %) of Canada in 2005 to that in 2007?
Make the answer very short. 1.03. What is the ratio of the Area (in %) in Croatia in 2005 to that in 2007?
Give a very brief answer. 1.01. What is the ratio of the Area (in %) of Slovak Republic in 2005 to that in 2007?
Your answer should be compact. 1.01. What is the ratio of the Area (in %) in Canada in 2005 to that in 2008?
Offer a very short reply. 1.05. What is the ratio of the Area (in %) in Croatia in 2005 to that in 2008?
Give a very brief answer. 0.94. What is the ratio of the Area (in %) of Finland in 2005 to that in 2008?
Ensure brevity in your answer.  0.99. What is the ratio of the Area (in %) of Slovak Republic in 2005 to that in 2008?
Offer a very short reply. 1. What is the ratio of the Area (in %) in Canada in 2005 to that in 2009?
Provide a short and direct response. 1.06. What is the ratio of the Area (in %) in Croatia in 2005 to that in 2009?
Your answer should be compact. 0.93. What is the ratio of the Area (in %) of Finland in 2005 to that in 2009?
Your answer should be compact. 0.99. What is the ratio of the Area (in %) of Slovak Republic in 2005 to that in 2009?
Keep it short and to the point. 1.01. What is the ratio of the Area (in %) in Canada in 2005 to that in 2010?
Give a very brief answer. 1.07. What is the ratio of the Area (in %) of Croatia in 2005 to that in 2010?
Your answer should be very brief. 0.91. What is the ratio of the Area (in %) of Canada in 2005 to that in 2011?
Ensure brevity in your answer.  1.08. What is the ratio of the Area (in %) in Croatia in 2005 to that in 2011?
Make the answer very short. 0.91. What is the ratio of the Area (in %) of Slovak Republic in 2005 to that in 2011?
Your response must be concise. 1.01. What is the ratio of the Area (in %) of Canada in 2005 to that in 2012?
Provide a succinct answer. 1.03. What is the ratio of the Area (in %) of Croatia in 2005 to that in 2012?
Keep it short and to the point. 0.91. What is the ratio of the Area (in %) of Slovak Republic in 2005 to that in 2012?
Provide a short and direct response. 1.01. What is the ratio of the Area (in %) of Canada in 2006 to that in 2007?
Make the answer very short. 1.01. What is the ratio of the Area (in %) in Croatia in 2006 to that in 2007?
Make the answer very short. 1.02. What is the ratio of the Area (in %) in Finland in 2006 to that in 2007?
Keep it short and to the point. 1. What is the ratio of the Area (in %) of Slovak Republic in 2006 to that in 2007?
Give a very brief answer. 1. What is the ratio of the Area (in %) of Canada in 2006 to that in 2008?
Your response must be concise. 1.02. What is the ratio of the Area (in %) of Croatia in 2006 to that in 2008?
Make the answer very short. 0.95. What is the ratio of the Area (in %) in Finland in 2006 to that in 2008?
Offer a very short reply. 1. What is the ratio of the Area (in %) of Slovak Republic in 2006 to that in 2008?
Make the answer very short. 1. What is the ratio of the Area (in %) of Canada in 2006 to that in 2009?
Provide a succinct answer. 1.03. What is the ratio of the Area (in %) of Croatia in 2006 to that in 2009?
Give a very brief answer. 0.95. What is the ratio of the Area (in %) in Finland in 2006 to that in 2009?
Offer a very short reply. 1. What is the ratio of the Area (in %) of Canada in 2006 to that in 2010?
Your response must be concise. 1.04. What is the ratio of the Area (in %) of Croatia in 2006 to that in 2010?
Your answer should be compact. 0.92. What is the ratio of the Area (in %) of Canada in 2006 to that in 2011?
Provide a short and direct response. 1.05. What is the ratio of the Area (in %) of Croatia in 2006 to that in 2011?
Your answer should be very brief. 0.93. What is the ratio of the Area (in %) in Finland in 2006 to that in 2011?
Your answer should be very brief. 1.01. What is the ratio of the Area (in %) of Canada in 2006 to that in 2012?
Your answer should be compact. 1.01. What is the ratio of the Area (in %) in Croatia in 2006 to that in 2012?
Ensure brevity in your answer.  0.92. What is the ratio of the Area (in %) in Slovak Republic in 2006 to that in 2012?
Offer a terse response. 1.01. What is the ratio of the Area (in %) in Canada in 2007 to that in 2008?
Ensure brevity in your answer.  1.01. What is the ratio of the Area (in %) of Croatia in 2007 to that in 2008?
Make the answer very short. 0.93. What is the ratio of the Area (in %) in Slovak Republic in 2007 to that in 2008?
Provide a short and direct response. 1. What is the ratio of the Area (in %) in Canada in 2007 to that in 2009?
Make the answer very short. 1.02. What is the ratio of the Area (in %) of Croatia in 2007 to that in 2009?
Ensure brevity in your answer.  0.92. What is the ratio of the Area (in %) of Canada in 2007 to that in 2010?
Keep it short and to the point. 1.03. What is the ratio of the Area (in %) in Croatia in 2007 to that in 2010?
Provide a short and direct response. 0.9. What is the ratio of the Area (in %) in Slovak Republic in 2007 to that in 2010?
Give a very brief answer. 0.99. What is the ratio of the Area (in %) of Canada in 2007 to that in 2011?
Make the answer very short. 1.04. What is the ratio of the Area (in %) in Croatia in 2007 to that in 2011?
Provide a short and direct response. 0.91. What is the ratio of the Area (in %) of Finland in 2007 to that in 2011?
Give a very brief answer. 1. What is the ratio of the Area (in %) of Croatia in 2007 to that in 2012?
Provide a succinct answer. 0.9. What is the ratio of the Area (in %) in Slovak Republic in 2007 to that in 2012?
Your answer should be very brief. 1. What is the ratio of the Area (in %) in Canada in 2008 to that in 2009?
Offer a very short reply. 1.01. What is the ratio of the Area (in %) in Croatia in 2008 to that in 2009?
Keep it short and to the point. 0.99. What is the ratio of the Area (in %) of Finland in 2008 to that in 2009?
Provide a short and direct response. 1. What is the ratio of the Area (in %) of Slovak Republic in 2008 to that in 2009?
Provide a succinct answer. 1. What is the ratio of the Area (in %) in Canada in 2008 to that in 2010?
Provide a succinct answer. 1.02. What is the ratio of the Area (in %) of Croatia in 2008 to that in 2010?
Offer a terse response. 0.97. What is the ratio of the Area (in %) in Slovak Republic in 2008 to that in 2010?
Make the answer very short. 1. What is the ratio of the Area (in %) in Canada in 2008 to that in 2011?
Offer a terse response. 1.03. What is the ratio of the Area (in %) of Croatia in 2008 to that in 2011?
Provide a succinct answer. 0.97. What is the ratio of the Area (in %) of Canada in 2008 to that in 2012?
Give a very brief answer. 0.99. What is the ratio of the Area (in %) in Croatia in 2008 to that in 2012?
Provide a short and direct response. 0.97. What is the ratio of the Area (in %) in Canada in 2009 to that in 2010?
Provide a short and direct response. 1.01. What is the ratio of the Area (in %) in Croatia in 2009 to that in 2010?
Offer a very short reply. 0.97. What is the ratio of the Area (in %) in Finland in 2009 to that in 2010?
Offer a terse response. 1. What is the ratio of the Area (in %) in Canada in 2009 to that in 2011?
Give a very brief answer. 1.02. What is the ratio of the Area (in %) in Finland in 2009 to that in 2011?
Provide a short and direct response. 1. What is the ratio of the Area (in %) of Canada in 2009 to that in 2012?
Your answer should be compact. 0.98. What is the ratio of the Area (in %) in Croatia in 2009 to that in 2012?
Your answer should be very brief. 0.98. What is the ratio of the Area (in %) of Canada in 2010 to that in 2011?
Offer a very short reply. 1.01. What is the ratio of the Area (in %) of Finland in 2010 to that in 2011?
Provide a succinct answer. 1. What is the ratio of the Area (in %) in Slovak Republic in 2010 to that in 2011?
Offer a terse response. 1.01. What is the ratio of the Area (in %) of Canada in 2010 to that in 2012?
Your answer should be very brief. 0.97. What is the ratio of the Area (in %) in Croatia in 2010 to that in 2012?
Your answer should be very brief. 1. What is the ratio of the Area (in %) in Finland in 2010 to that in 2012?
Give a very brief answer. 1. What is the ratio of the Area (in %) in Slovak Republic in 2010 to that in 2012?
Offer a terse response. 1.01. What is the ratio of the Area (in %) in Canada in 2011 to that in 2012?
Keep it short and to the point. 0.96. What is the ratio of the Area (in %) in Finland in 2011 to that in 2012?
Keep it short and to the point. 1. What is the ratio of the Area (in %) of Slovak Republic in 2011 to that in 2012?
Your answer should be compact. 1. What is the difference between the highest and the second highest Area (in %) of Canada?
Your answer should be compact. 0.18. What is the difference between the highest and the second highest Area (in %) in Finland?
Offer a terse response. 0.01. What is the difference between the highest and the second highest Area (in %) of Slovak Republic?
Keep it short and to the point. 0.08. What is the difference between the highest and the lowest Area (in %) in Canada?
Provide a short and direct response. 0.55. What is the difference between the highest and the lowest Area (in %) in Croatia?
Your response must be concise. 2.36. What is the difference between the highest and the lowest Area (in %) in Finland?
Make the answer very short. 0.1. What is the difference between the highest and the lowest Area (in %) in Slovak Republic?
Give a very brief answer. 0.36. 